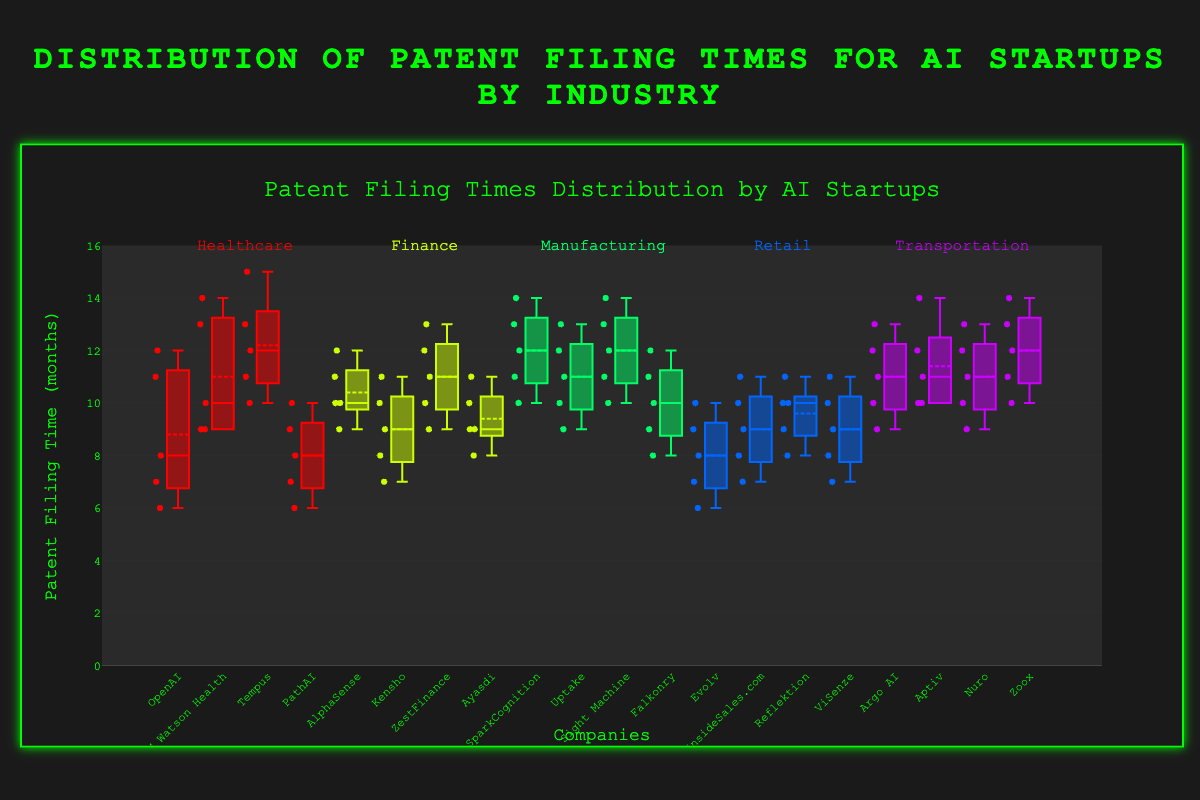What's the title of the figure? The figure's title is usually placed at the top, and it serves as a brief description of the visualized data.
Answer: Distribution of Patent Filing Times for AI Startups by Industry How many industries are represented in the figure? To determine the number of industries, check the annotations or group labels on the x-axis, which are usually clustered together or noted separately.
Answer: 5 Which company in the Healthcare industry has the widest range of patent filing times? By looking at the length of the whiskers or span of the box for Healthcare companies, the one with the largest spread can be identified.
Answer: IBM Watson Health What's the median patent filing time for OpenAI in Healthcare? The median is represented by the line inside the box, so pinpointing it will give us the answer.
Answer: 8 Compare the interquartile ranges (IQR) of AlphaSense and Kensho in Finance. Which one is larger? The IQR is the distance between the first and third quartile (bottom and top of the box). Measure and compare the spans of these boxes for AlphaSense and Kensho.
Answer: AlphaSense Which industry has the highest median patent filing time overall? The industry median can be found by comparing the median lines within each industry. Highest median patent filing time can be pinpointed by observing which line is positioned highest on the y-axis.
Answer: Transportation How does the median patent filing time of SparkCognition compare to Falkonry in Manufacturing? Compare the median lines inside the boxes of SparkCognition and Falkonry to see which one is placed higher or lower.
Answer: SparkCognition is higher Identify the company in the Retail industry with the lowest minimum patent filing time. The minimum is represented by the end of the lower whisker. Identify which company's lower whisker extends the furthest down.
Answer: Evolv What is the median value for the company with the most consistent (least variable) patent filing times in the Transportation industry? Consistency can be judged by the size of the box (IQR). The smallest box in Transportation corresponds to the most consistent company, then find its median line.
Answer: Aptiv, 11 Which Retail company has the highest upper whisker value? Look for the company in Retail whose upper whisker stretches the highest on the y-axis.
Answer: ViSenze 